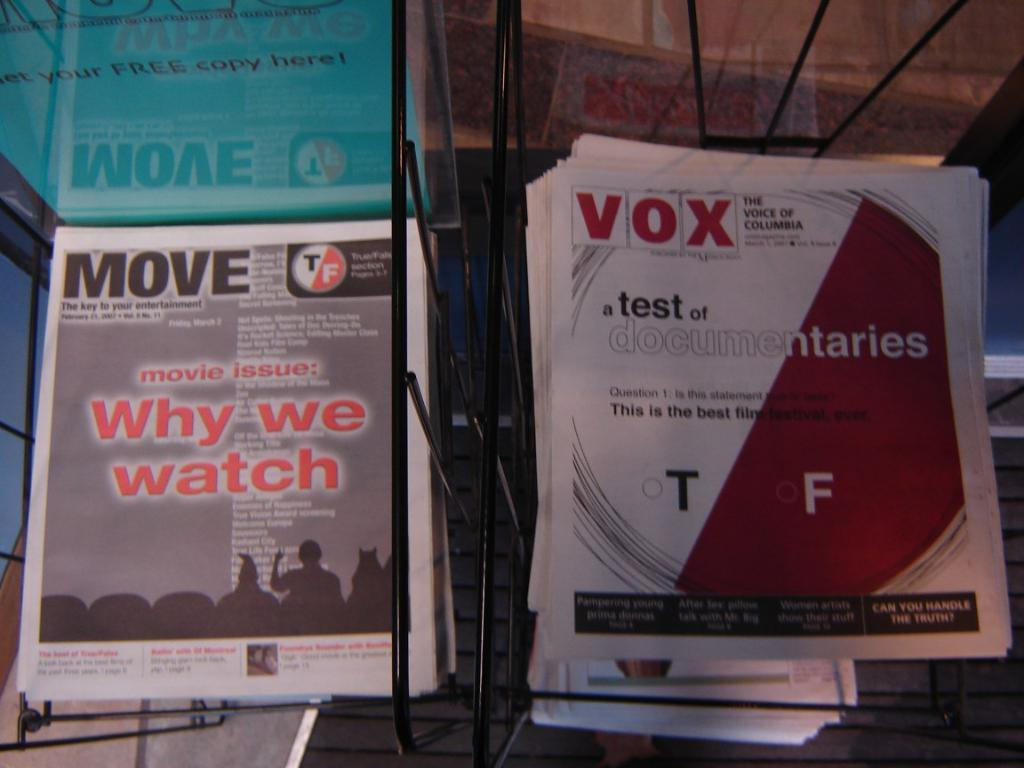<image>
Write a terse but informative summary of the picture. A pair of stack of paper magazines, one is called Vox. 